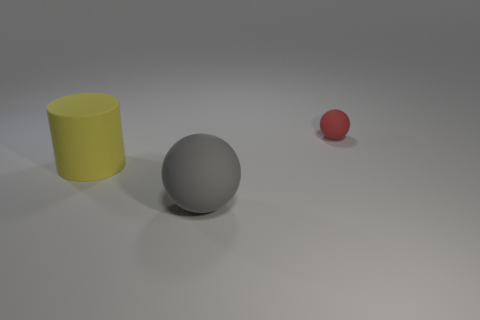Add 2 gray rubber objects. How many objects exist? 5 Subtract all spheres. How many objects are left? 1 Subtract 0 green cylinders. How many objects are left? 3 Subtract all gray rubber cylinders. Subtract all tiny red objects. How many objects are left? 2 Add 1 big gray matte spheres. How many big gray matte spheres are left? 2 Add 3 large rubber cylinders. How many large rubber cylinders exist? 4 